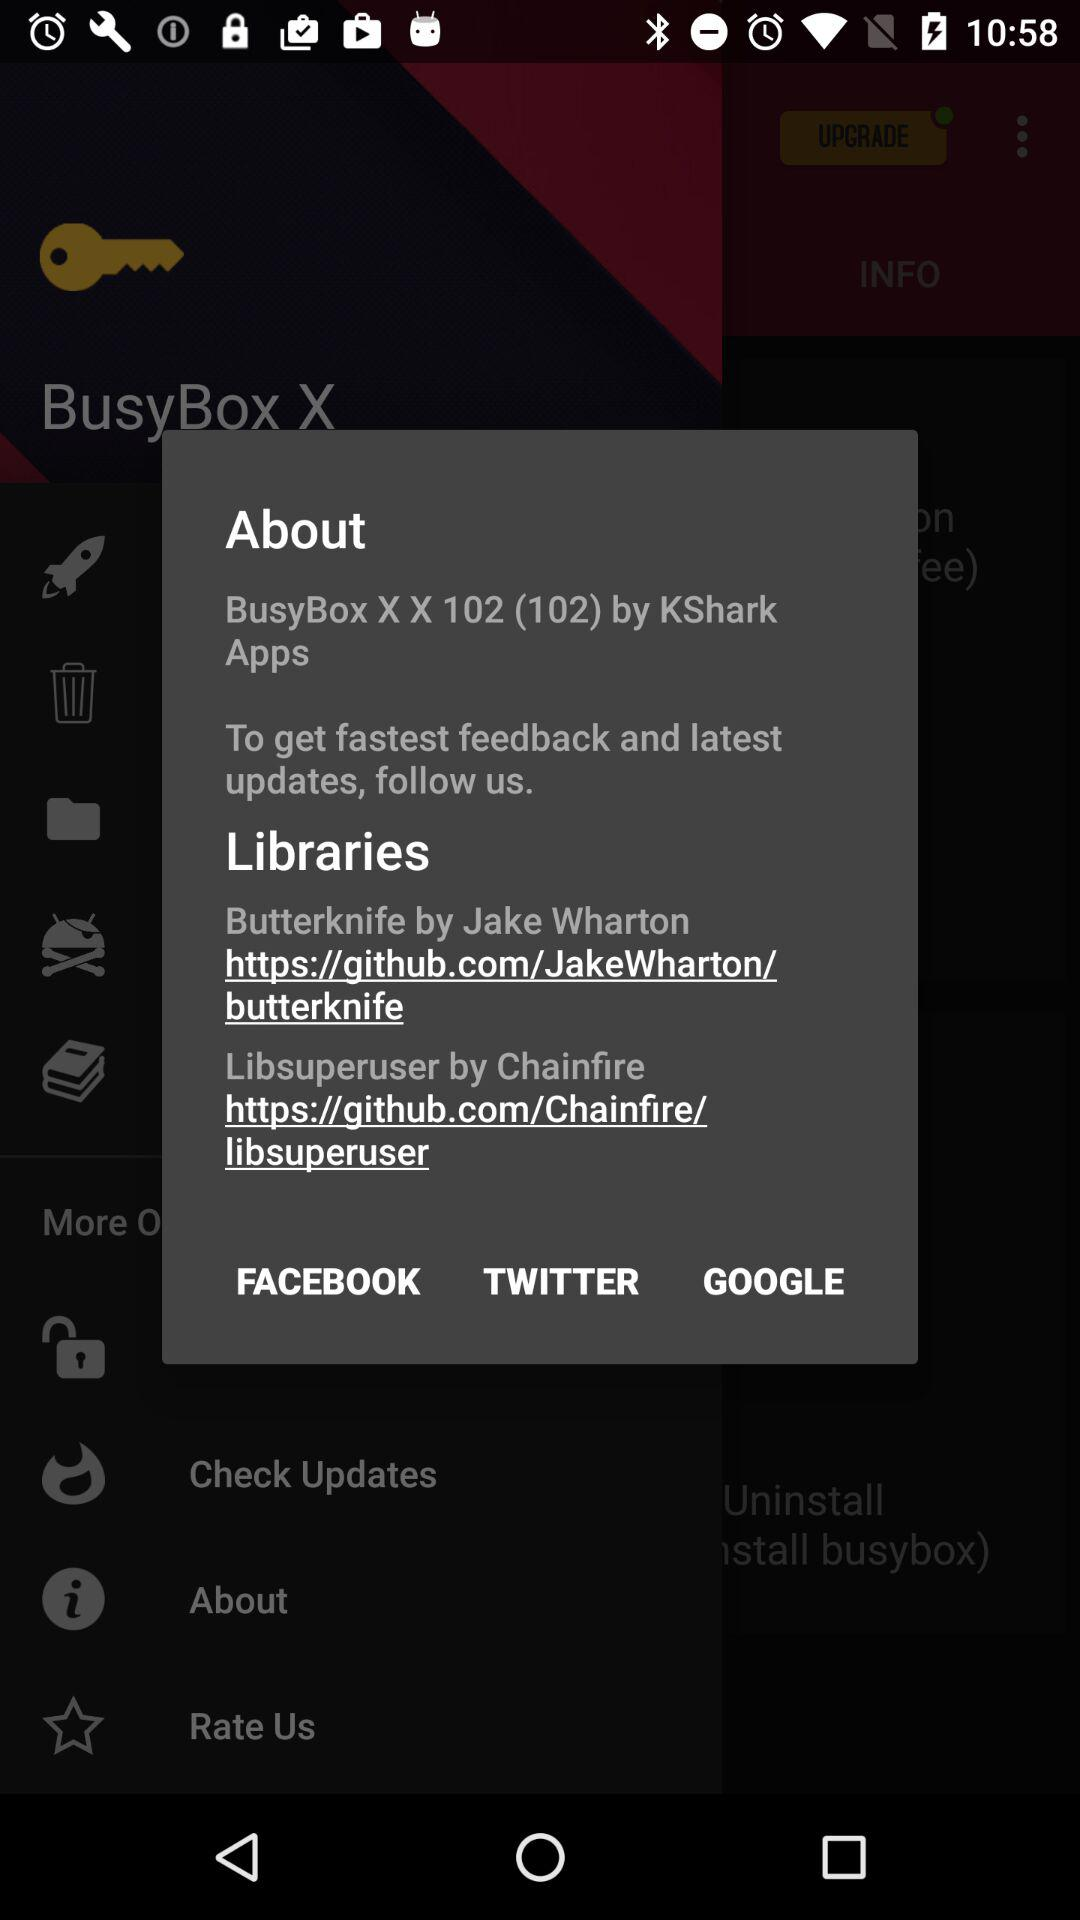How many libraries are mentioned in the about page?
Answer the question using a single word or phrase. 2 